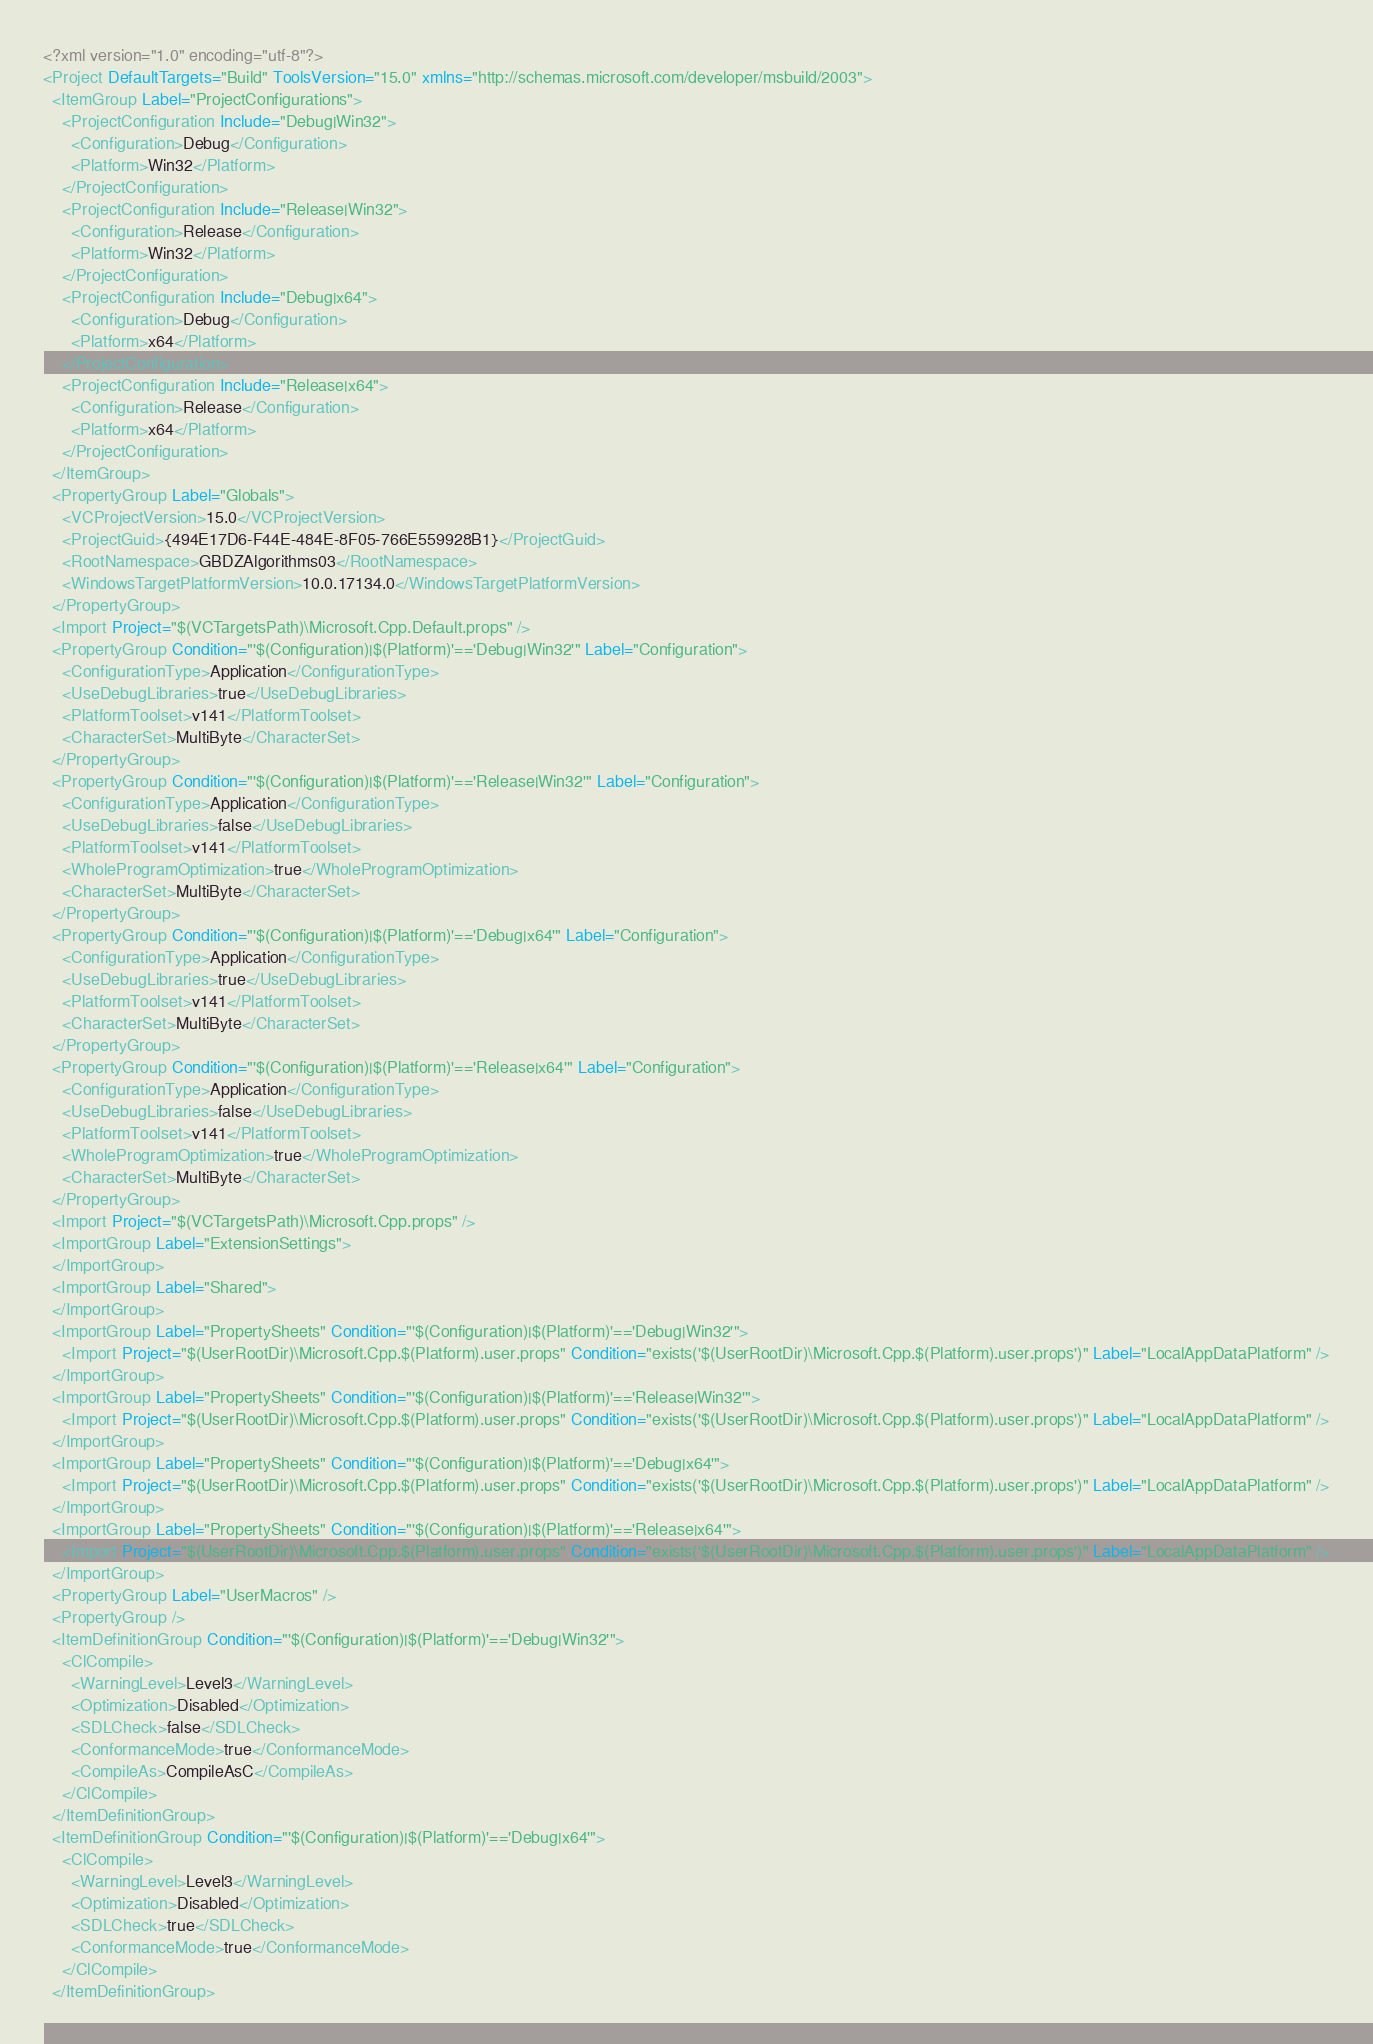Convert code to text. <code><loc_0><loc_0><loc_500><loc_500><_XML_><?xml version="1.0" encoding="utf-8"?>
<Project DefaultTargets="Build" ToolsVersion="15.0" xmlns="http://schemas.microsoft.com/developer/msbuild/2003">
  <ItemGroup Label="ProjectConfigurations">
    <ProjectConfiguration Include="Debug|Win32">
      <Configuration>Debug</Configuration>
      <Platform>Win32</Platform>
    </ProjectConfiguration>
    <ProjectConfiguration Include="Release|Win32">
      <Configuration>Release</Configuration>
      <Platform>Win32</Platform>
    </ProjectConfiguration>
    <ProjectConfiguration Include="Debug|x64">
      <Configuration>Debug</Configuration>
      <Platform>x64</Platform>
    </ProjectConfiguration>
    <ProjectConfiguration Include="Release|x64">
      <Configuration>Release</Configuration>
      <Platform>x64</Platform>
    </ProjectConfiguration>
  </ItemGroup>
  <PropertyGroup Label="Globals">
    <VCProjectVersion>15.0</VCProjectVersion>
    <ProjectGuid>{494E17D6-F44E-484E-8F05-766E559928B1}</ProjectGuid>
    <RootNamespace>GBDZAlgorithms03</RootNamespace>
    <WindowsTargetPlatformVersion>10.0.17134.0</WindowsTargetPlatformVersion>
  </PropertyGroup>
  <Import Project="$(VCTargetsPath)\Microsoft.Cpp.Default.props" />
  <PropertyGroup Condition="'$(Configuration)|$(Platform)'=='Debug|Win32'" Label="Configuration">
    <ConfigurationType>Application</ConfigurationType>
    <UseDebugLibraries>true</UseDebugLibraries>
    <PlatformToolset>v141</PlatformToolset>
    <CharacterSet>MultiByte</CharacterSet>
  </PropertyGroup>
  <PropertyGroup Condition="'$(Configuration)|$(Platform)'=='Release|Win32'" Label="Configuration">
    <ConfigurationType>Application</ConfigurationType>
    <UseDebugLibraries>false</UseDebugLibraries>
    <PlatformToolset>v141</PlatformToolset>
    <WholeProgramOptimization>true</WholeProgramOptimization>
    <CharacterSet>MultiByte</CharacterSet>
  </PropertyGroup>
  <PropertyGroup Condition="'$(Configuration)|$(Platform)'=='Debug|x64'" Label="Configuration">
    <ConfigurationType>Application</ConfigurationType>
    <UseDebugLibraries>true</UseDebugLibraries>
    <PlatformToolset>v141</PlatformToolset>
    <CharacterSet>MultiByte</CharacterSet>
  </PropertyGroup>
  <PropertyGroup Condition="'$(Configuration)|$(Platform)'=='Release|x64'" Label="Configuration">
    <ConfigurationType>Application</ConfigurationType>
    <UseDebugLibraries>false</UseDebugLibraries>
    <PlatformToolset>v141</PlatformToolset>
    <WholeProgramOptimization>true</WholeProgramOptimization>
    <CharacterSet>MultiByte</CharacterSet>
  </PropertyGroup>
  <Import Project="$(VCTargetsPath)\Microsoft.Cpp.props" />
  <ImportGroup Label="ExtensionSettings">
  </ImportGroup>
  <ImportGroup Label="Shared">
  </ImportGroup>
  <ImportGroup Label="PropertySheets" Condition="'$(Configuration)|$(Platform)'=='Debug|Win32'">
    <Import Project="$(UserRootDir)\Microsoft.Cpp.$(Platform).user.props" Condition="exists('$(UserRootDir)\Microsoft.Cpp.$(Platform).user.props')" Label="LocalAppDataPlatform" />
  </ImportGroup>
  <ImportGroup Label="PropertySheets" Condition="'$(Configuration)|$(Platform)'=='Release|Win32'">
    <Import Project="$(UserRootDir)\Microsoft.Cpp.$(Platform).user.props" Condition="exists('$(UserRootDir)\Microsoft.Cpp.$(Platform).user.props')" Label="LocalAppDataPlatform" />
  </ImportGroup>
  <ImportGroup Label="PropertySheets" Condition="'$(Configuration)|$(Platform)'=='Debug|x64'">
    <Import Project="$(UserRootDir)\Microsoft.Cpp.$(Platform).user.props" Condition="exists('$(UserRootDir)\Microsoft.Cpp.$(Platform).user.props')" Label="LocalAppDataPlatform" />
  </ImportGroup>
  <ImportGroup Label="PropertySheets" Condition="'$(Configuration)|$(Platform)'=='Release|x64'">
    <Import Project="$(UserRootDir)\Microsoft.Cpp.$(Platform).user.props" Condition="exists('$(UserRootDir)\Microsoft.Cpp.$(Platform).user.props')" Label="LocalAppDataPlatform" />
  </ImportGroup>
  <PropertyGroup Label="UserMacros" />
  <PropertyGroup />
  <ItemDefinitionGroup Condition="'$(Configuration)|$(Platform)'=='Debug|Win32'">
    <ClCompile>
      <WarningLevel>Level3</WarningLevel>
      <Optimization>Disabled</Optimization>
      <SDLCheck>false</SDLCheck>
      <ConformanceMode>true</ConformanceMode>
      <CompileAs>CompileAsC</CompileAs>
    </ClCompile>
  </ItemDefinitionGroup>
  <ItemDefinitionGroup Condition="'$(Configuration)|$(Platform)'=='Debug|x64'">
    <ClCompile>
      <WarningLevel>Level3</WarningLevel>
      <Optimization>Disabled</Optimization>
      <SDLCheck>true</SDLCheck>
      <ConformanceMode>true</ConformanceMode>
    </ClCompile>
  </ItemDefinitionGroup></code> 